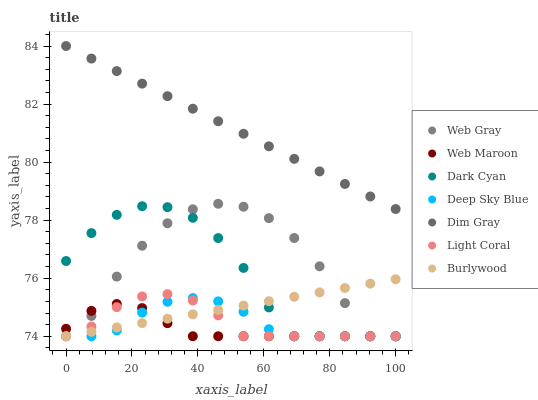Does Web Maroon have the minimum area under the curve?
Answer yes or no. Yes. Does Dim Gray have the maximum area under the curve?
Answer yes or no. Yes. Does Burlywood have the minimum area under the curve?
Answer yes or no. No. Does Burlywood have the maximum area under the curve?
Answer yes or no. No. Is Burlywood the smoothest?
Answer yes or no. Yes. Is Web Gray the roughest?
Answer yes or no. Yes. Is Web Maroon the smoothest?
Answer yes or no. No. Is Web Maroon the roughest?
Answer yes or no. No. Does Burlywood have the lowest value?
Answer yes or no. Yes. Does Dim Gray have the highest value?
Answer yes or no. Yes. Does Burlywood have the highest value?
Answer yes or no. No. Is Web Gray less than Dim Gray?
Answer yes or no. Yes. Is Dim Gray greater than Web Maroon?
Answer yes or no. Yes. Does Web Gray intersect Burlywood?
Answer yes or no. Yes. Is Web Gray less than Burlywood?
Answer yes or no. No. Is Web Gray greater than Burlywood?
Answer yes or no. No. Does Web Gray intersect Dim Gray?
Answer yes or no. No. 